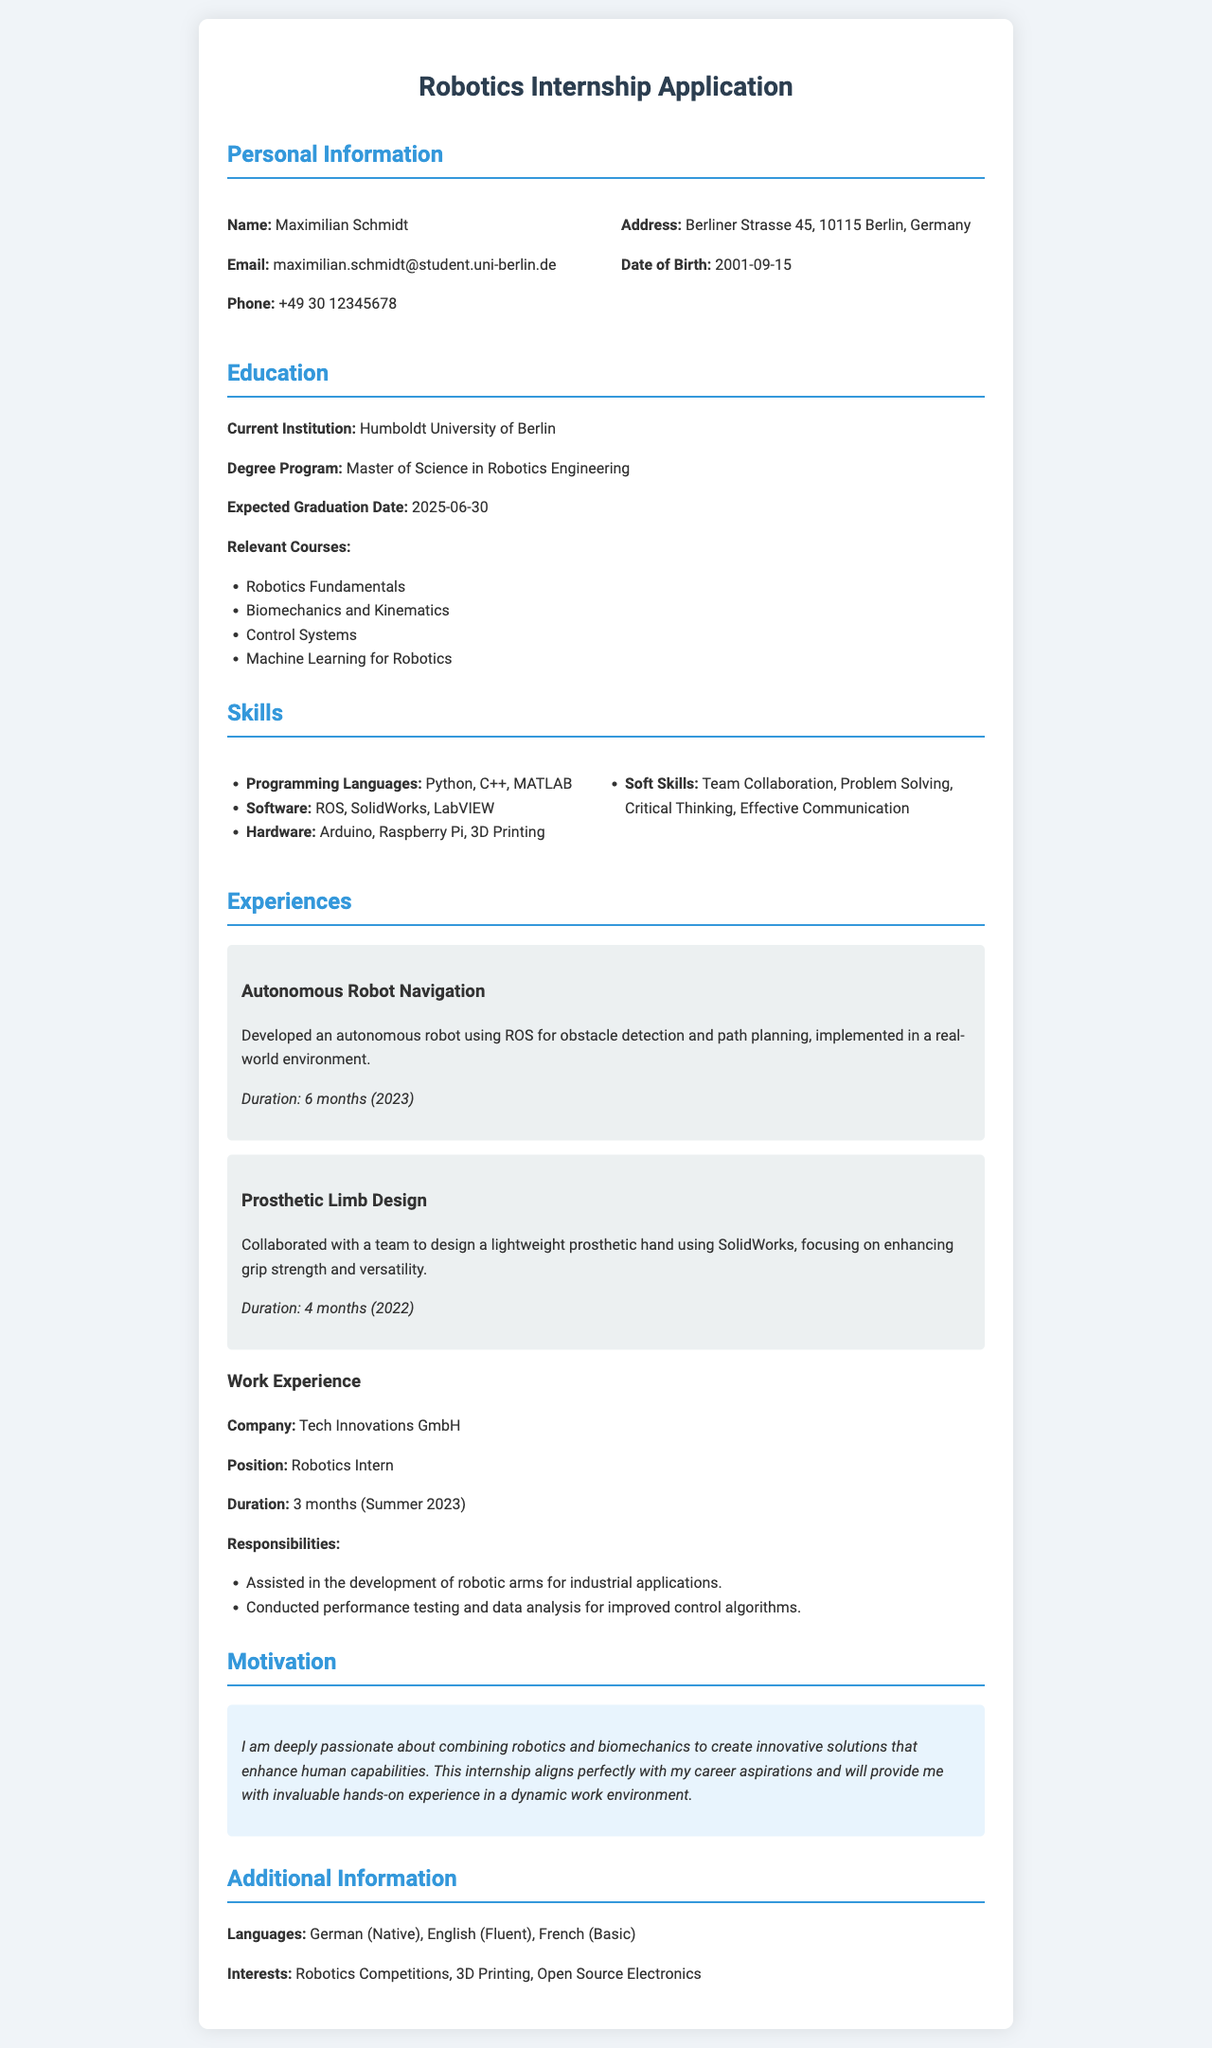What is the name of the applicant? The document provides the name of the applicant, which is listed under personal information.
Answer: Maximilian Schmidt What is the current degree program? The degree program is specified in the education section of the document.
Answer: Master of Science in Robotics Engineering What is the expected graduation date? The expected graduation date is found in the education section, providing an important timeline for the applicant's education.
Answer: 2025-06-30 Which programming languages are mentioned in the skills section? The skills section lists various programming languages the applicant is proficient in.
Answer: Python, C++, MATLAB What project involved the design of a prosthetic hand? The experiences section describes various projects undertaken by the applicant, specifying their contributions and focus.
Answer: Prosthetic Limb Design What company did the applicant intern with? The work experience section specifies the company where the applicant gained practical experience during their internship.
Answer: Tech Innovations GmbH How long did the autonomous robot navigation project last? The duration of the project is mentioned in its description, highlighting the applicant's commitment to practical learning.
Answer: 6 months Which soft skill is highlighted in the skills section? The skills section outlines various soft skills, emphasizing interpersonal abilities relevant to the role.
Answer: Team Collaboration What year was the prosthetic limb design project completed? The duration of the project is provided to give context on when the applicant engaged in this experience.
Answer: 2022 